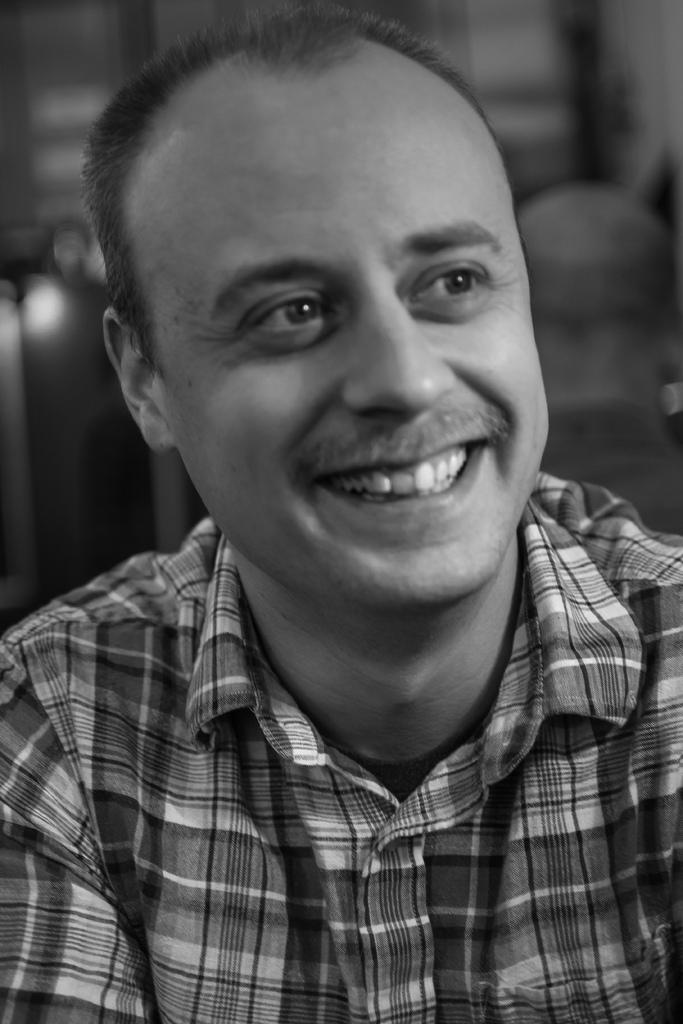What is present in the image? There is a person in the image. How is the person's expression in the image? The person is smiling. What type of oatmeal is being served for lunch in the image? There is no oatmeal or lunch depicted in the image; it only shows a person smiling. 